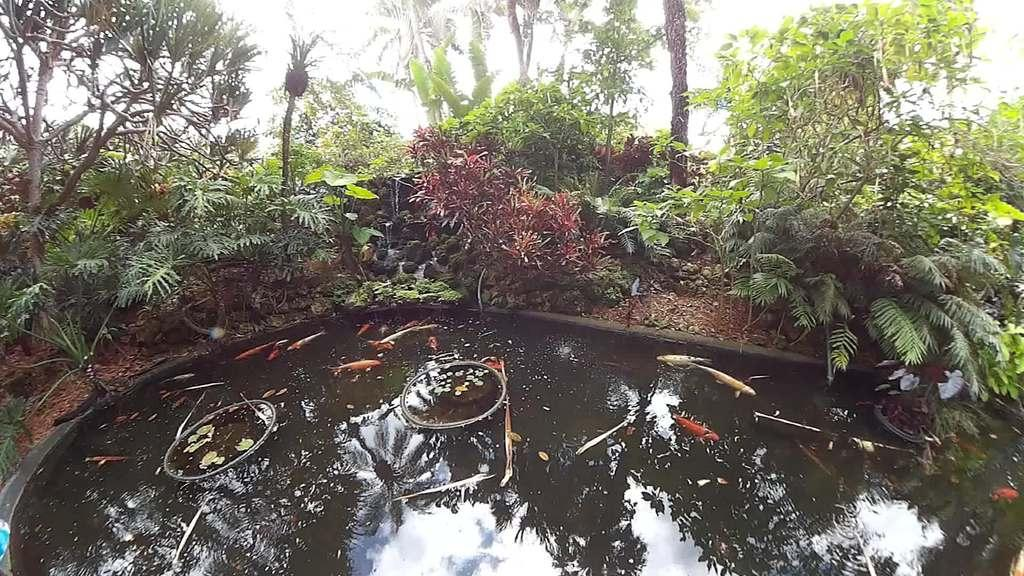What is located at the bottom of the image? There is a small pond at the bottom of the image. What can be found in the pond? There are fishes in the pond. What is visible in the background of the image? There are trees and plants in the background of the background of the image. How many geese are swimming in the pond in the image? There are no geese present in the image; it only features a small pond with fishes. What type of screw is being used to hold the plants in the image? There is no screw visible in the image; it only shows a small pond, fishes, trees, and plants. 